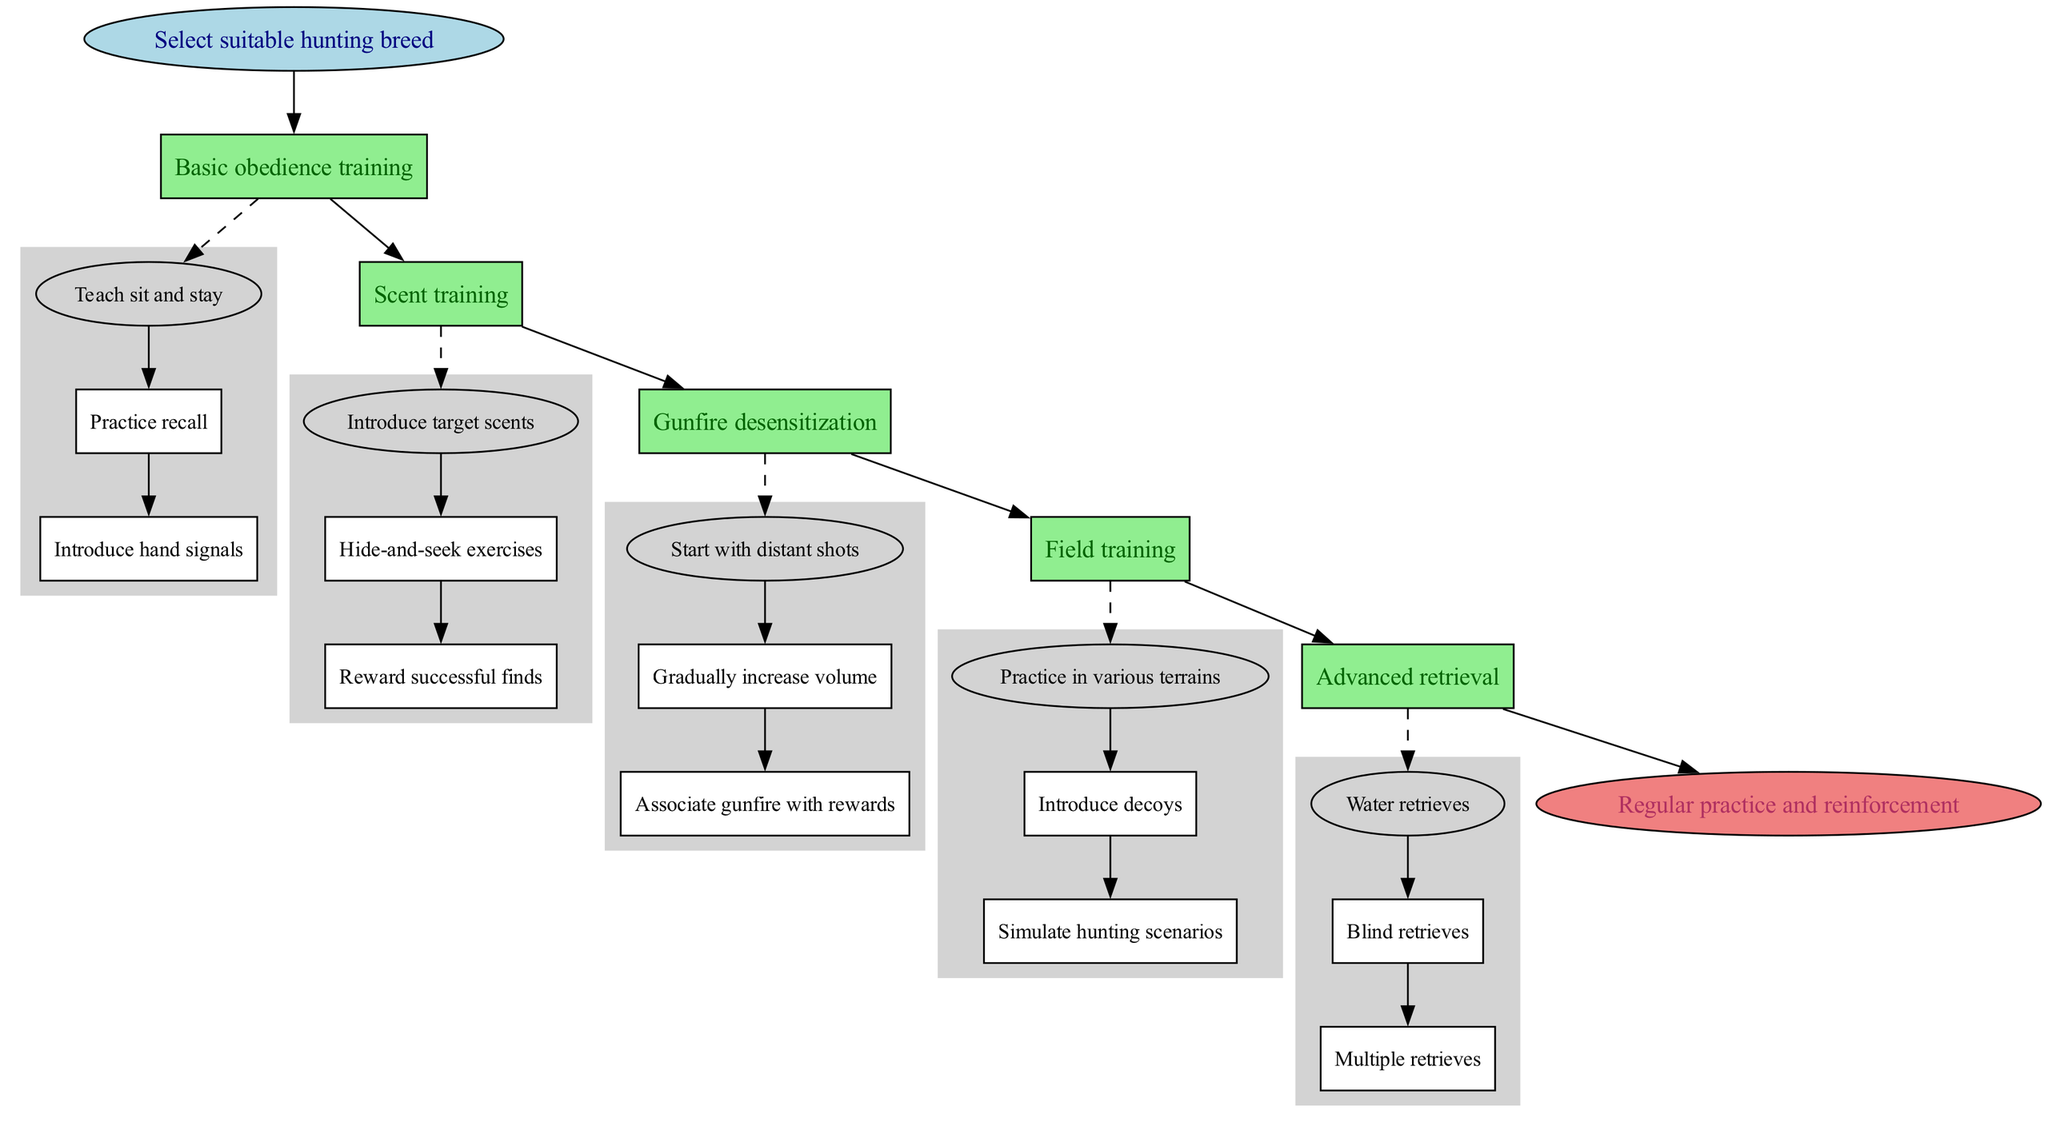What is the first step in training a hunting dog? The diagram begins with the "Select suitable hunting breed" node, which represents the initial step in the training process.
Answer: Select suitable hunting breed How many steps are involved in the training process? Counting the total nodes representing the main steps in the diagram, there are five main steps listed after the start node.
Answer: 5 What is the last step indicated in the diagram? The diagram ends with the "Regular practice and reinforcement" node, which signifies the concluding step after the main training activities.
Answer: Regular practice and reinforcement Which step involves introducing target scents? The step titled "Scent training" explicitly includes the activity of introducing target scents as part of the training process.
Answer: Scent training What type of training follows basic obedience training? After the "Basic obedience training" step, the subsequent step in the flow is "Scent training", indicating that it follows directly in the training sequence.
Answer: Scent training What method is used to associate gunfire with rewards? In the "Gunfire desensitization" step, the method used to associate gunfire with rewards is clearly stated as part of the substeps.
Answer: Associate gunfire with rewards How are the substeps under training steps represented in the diagram? Substeps are shown as nodes connected to their corresponding step node with dashed edges, indicating a hierarchical structure of training actions.
Answer: Dashed edges What is a key element introduced during field training? One of the key elements introduced in "Field training" is "decoys", which serves as an integral part of simulating hunting scenarios.
Answer: Decoys Which substep occurs before practicing recall? In the "Basic obedience training" section, the substep "Teach sit and stay" is the first action that takes place before practicing recall.
Answer: Teach sit and stay 